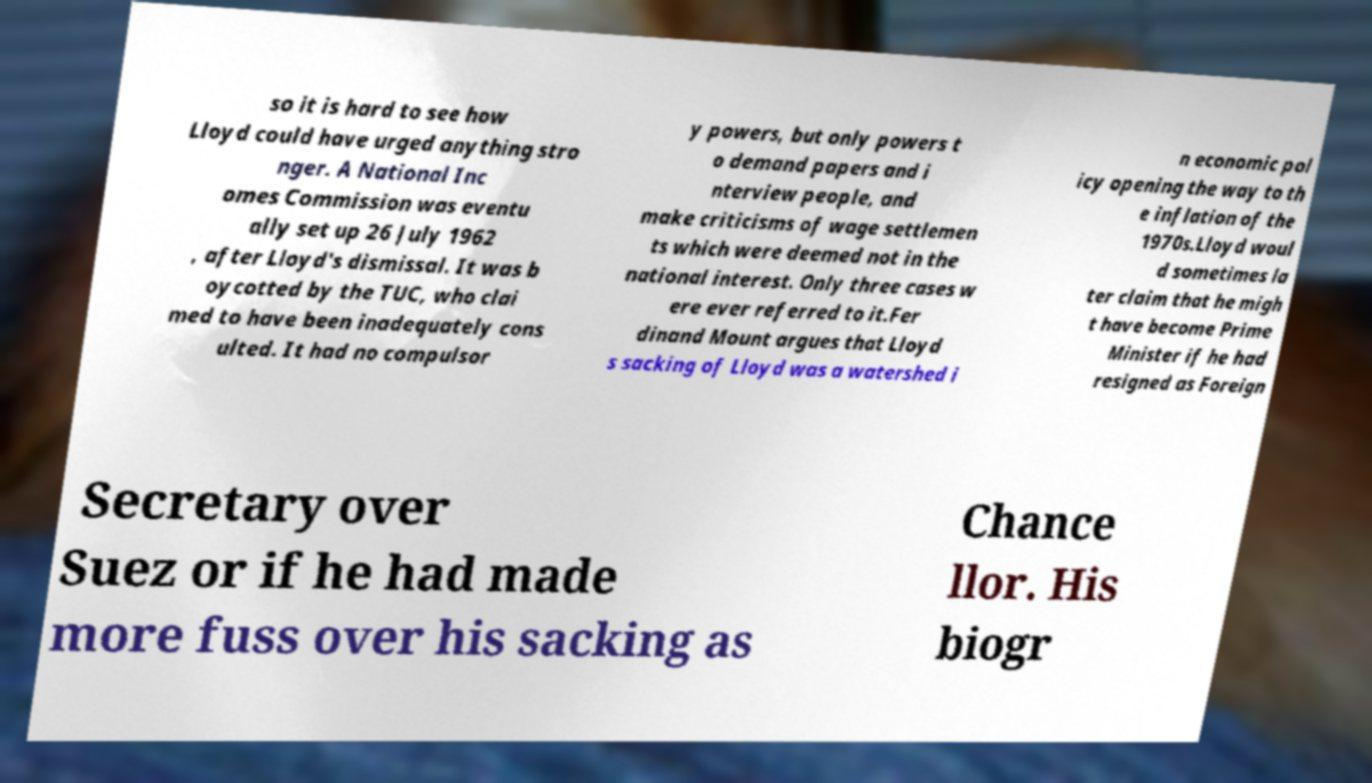I need the written content from this picture converted into text. Can you do that? so it is hard to see how Lloyd could have urged anything stro nger. A National Inc omes Commission was eventu ally set up 26 July 1962 , after Lloyd's dismissal. It was b oycotted by the TUC, who clai med to have been inadequately cons ulted. It had no compulsor y powers, but only powers t o demand papers and i nterview people, and make criticisms of wage settlemen ts which were deemed not in the national interest. Only three cases w ere ever referred to it.Fer dinand Mount argues that Lloyd s sacking of Lloyd was a watershed i n economic pol icy opening the way to th e inflation of the 1970s.Lloyd woul d sometimes la ter claim that he migh t have become Prime Minister if he had resigned as Foreign Secretary over Suez or if he had made more fuss over his sacking as Chance llor. His biogr 